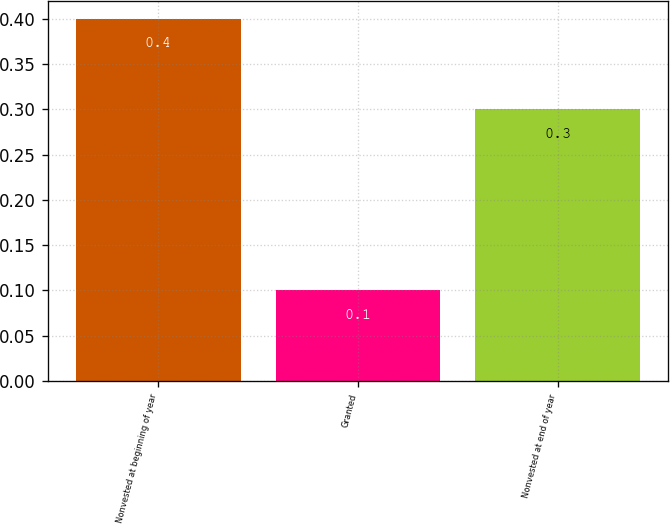Convert chart to OTSL. <chart><loc_0><loc_0><loc_500><loc_500><bar_chart><fcel>Nonvested at beginning of year<fcel>Granted<fcel>Nonvested at end of year<nl><fcel>0.4<fcel>0.1<fcel>0.3<nl></chart> 